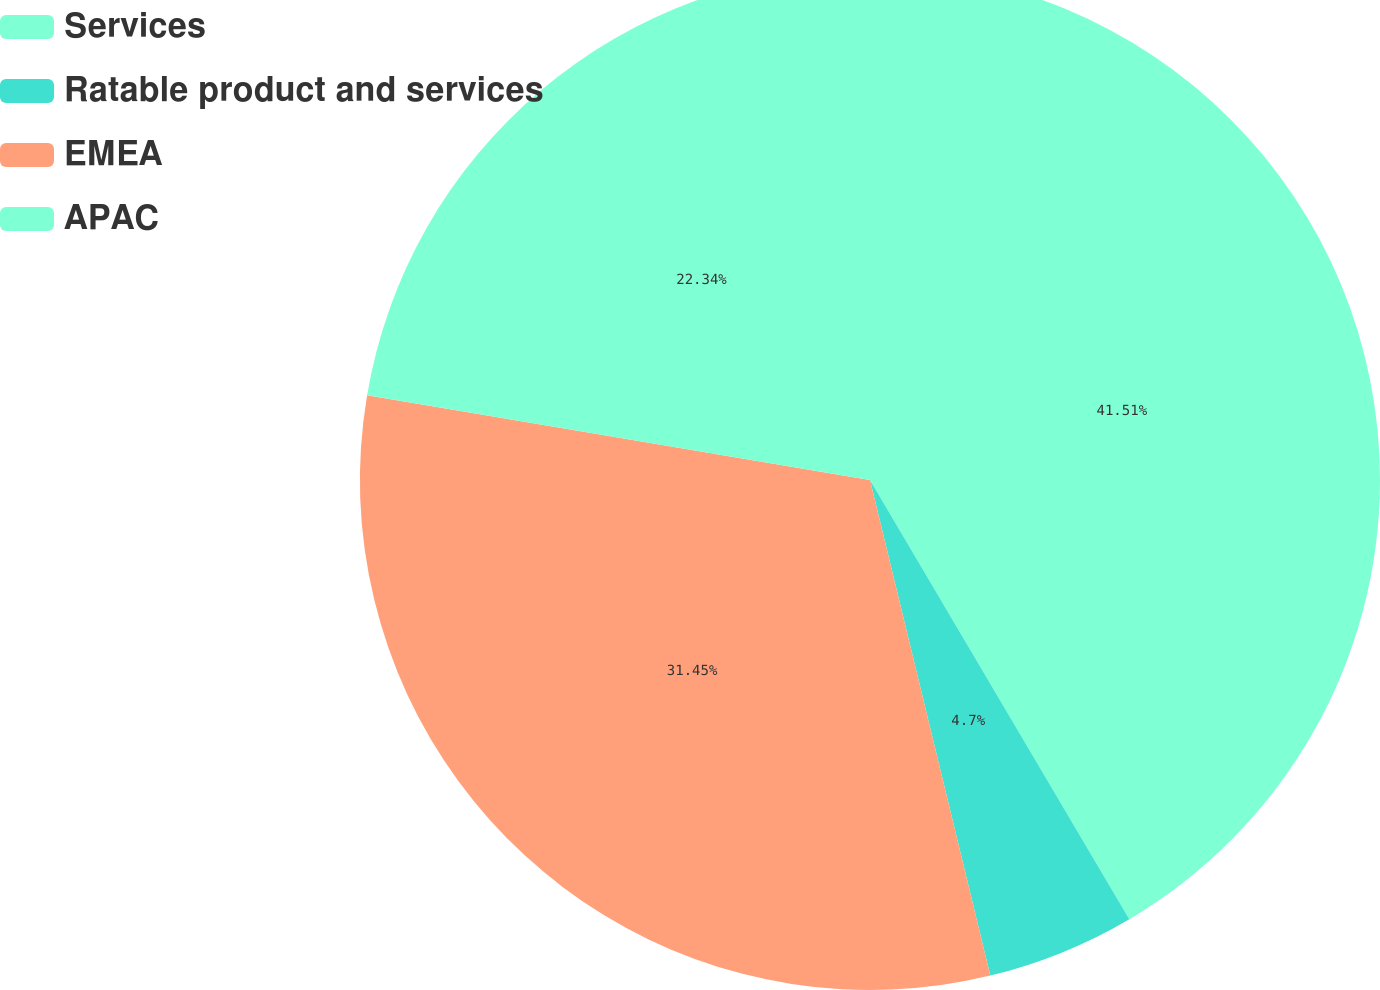<chart> <loc_0><loc_0><loc_500><loc_500><pie_chart><fcel>Services<fcel>Ratable product and services<fcel>EMEA<fcel>APAC<nl><fcel>41.51%<fcel>4.7%<fcel>31.45%<fcel>22.34%<nl></chart> 